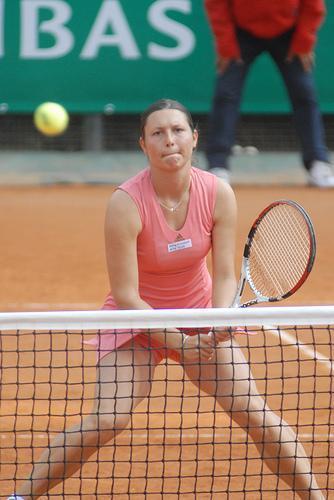How many people are in the photo?
Give a very brief answer. 2. How many people are wearing a red shirt?
Give a very brief answer. 1. How many people are wearing a pink tennis outfit?
Give a very brief answer. 1. 